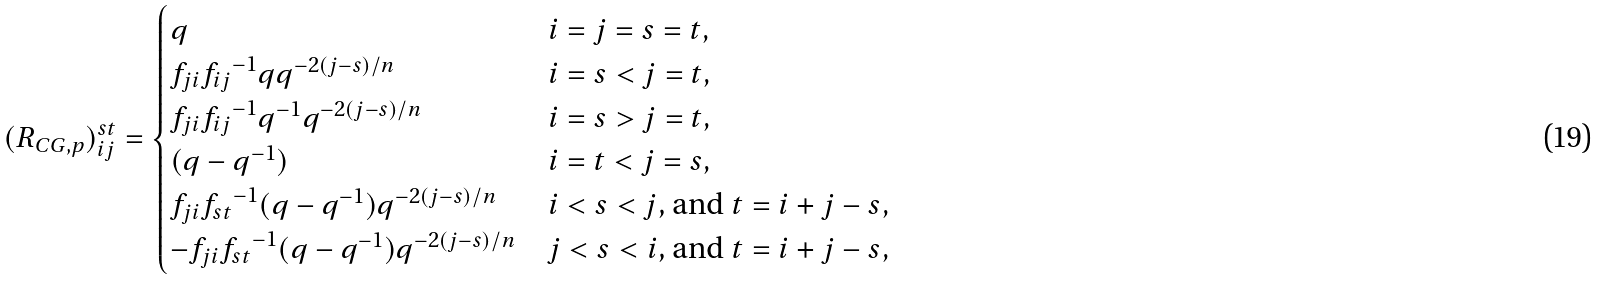<formula> <loc_0><loc_0><loc_500><loc_500>( R _ { C G , p } ) _ { i j } ^ { s t } = \begin{cases} q & \text {$i=j=s=t$} , \\ f _ { j i } { f _ { i j } } ^ { - 1 } q q ^ { - 2 ( j - s ) / n } & \text {$i=s<j=t$} , \\ f _ { j i } { f _ { i j } } ^ { - 1 } q ^ { - 1 } q ^ { - 2 ( j - s ) / n } & \text {$i=s>j=t$} , \\ ( q - q ^ { - 1 } ) & \text {$i=t<j=s$} , \\ f _ { j i } { f _ { s t } } ^ { - 1 } ( q - q ^ { - 1 } ) q ^ { - 2 ( j - s ) / n } & \text {$i<s<j$, and $t=i+j-s$} , \\ - f _ { j i } { f _ { s t } } ^ { - 1 } ( q - q ^ { - 1 } ) q ^ { - 2 ( j - s ) / n } & \text {$j<s<i$, and $t=i+j-s$} , \end{cases}</formula> 